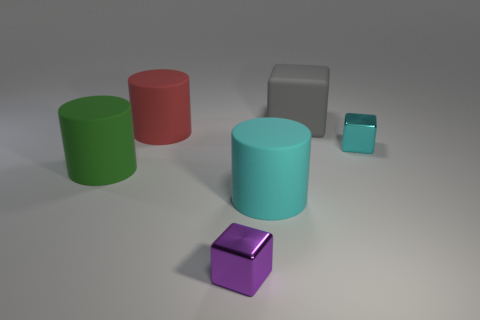What material is the gray thing that is behind the rubber cylinder to the right of the small metallic cube to the left of the big gray thing?
Your answer should be very brief. Rubber. How many things are big cyan cylinders or tiny brown rubber blocks?
Your answer should be very brief. 1. Is the material of the cyan object that is behind the large green thing the same as the gray cube?
Ensure brevity in your answer.  No. What number of objects are either small things that are in front of the tiny cyan object or blue shiny objects?
Offer a very short reply. 1. What is the color of the big cube that is made of the same material as the big green cylinder?
Keep it short and to the point. Gray. Are there any things of the same size as the purple cube?
Keep it short and to the point. Yes. What is the color of the big matte thing that is on the right side of the tiny purple shiny thing and in front of the big gray matte object?
Your response must be concise. Cyan. What shape is the gray object that is the same size as the green rubber thing?
Offer a terse response. Cube. Are there any big red things that have the same shape as the gray thing?
Provide a short and direct response. No. There is a thing on the left side of the red cylinder; is it the same size as the red cylinder?
Give a very brief answer. Yes. 